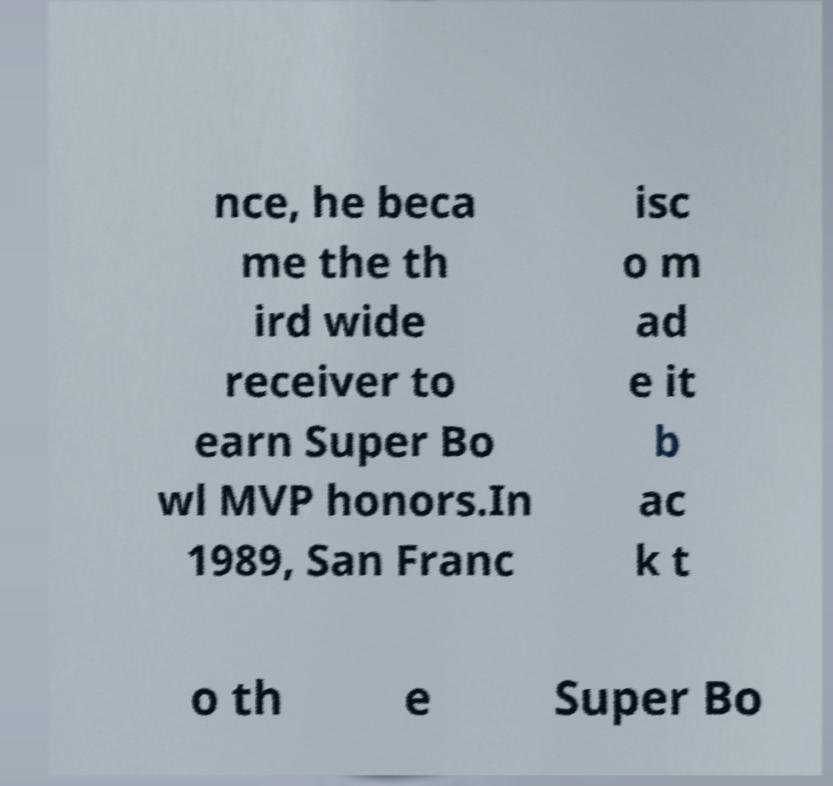Please identify and transcribe the text found in this image. nce, he beca me the th ird wide receiver to earn Super Bo wl MVP honors.In 1989, San Franc isc o m ad e it b ac k t o th e Super Bo 